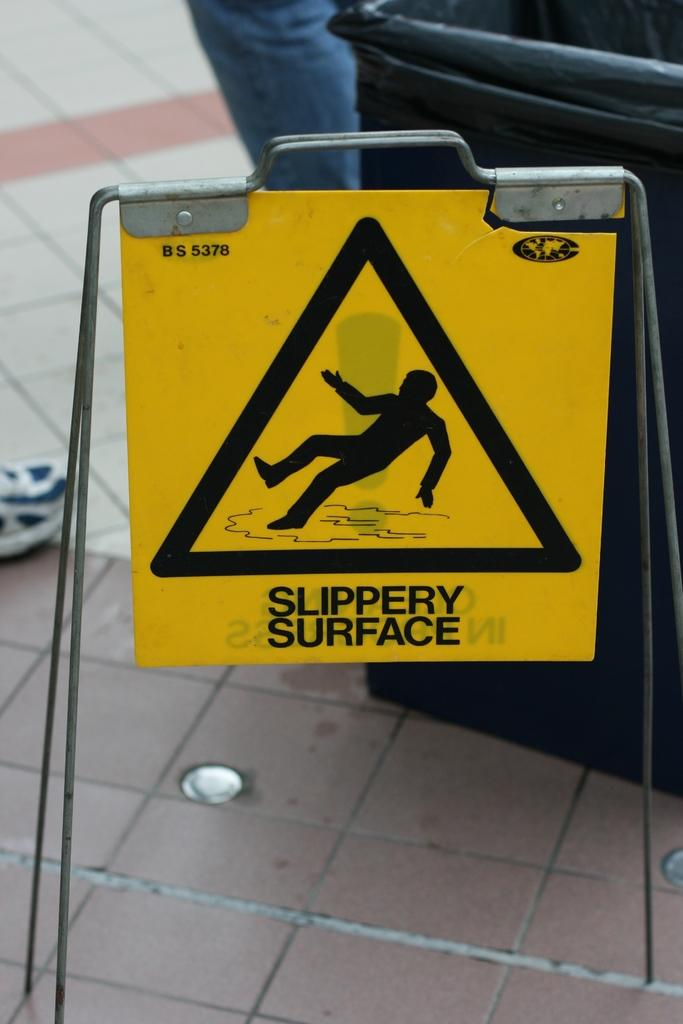<image>
Give a short and clear explanation of the subsequent image. A yellow sign warns people that the surface is slippery. 